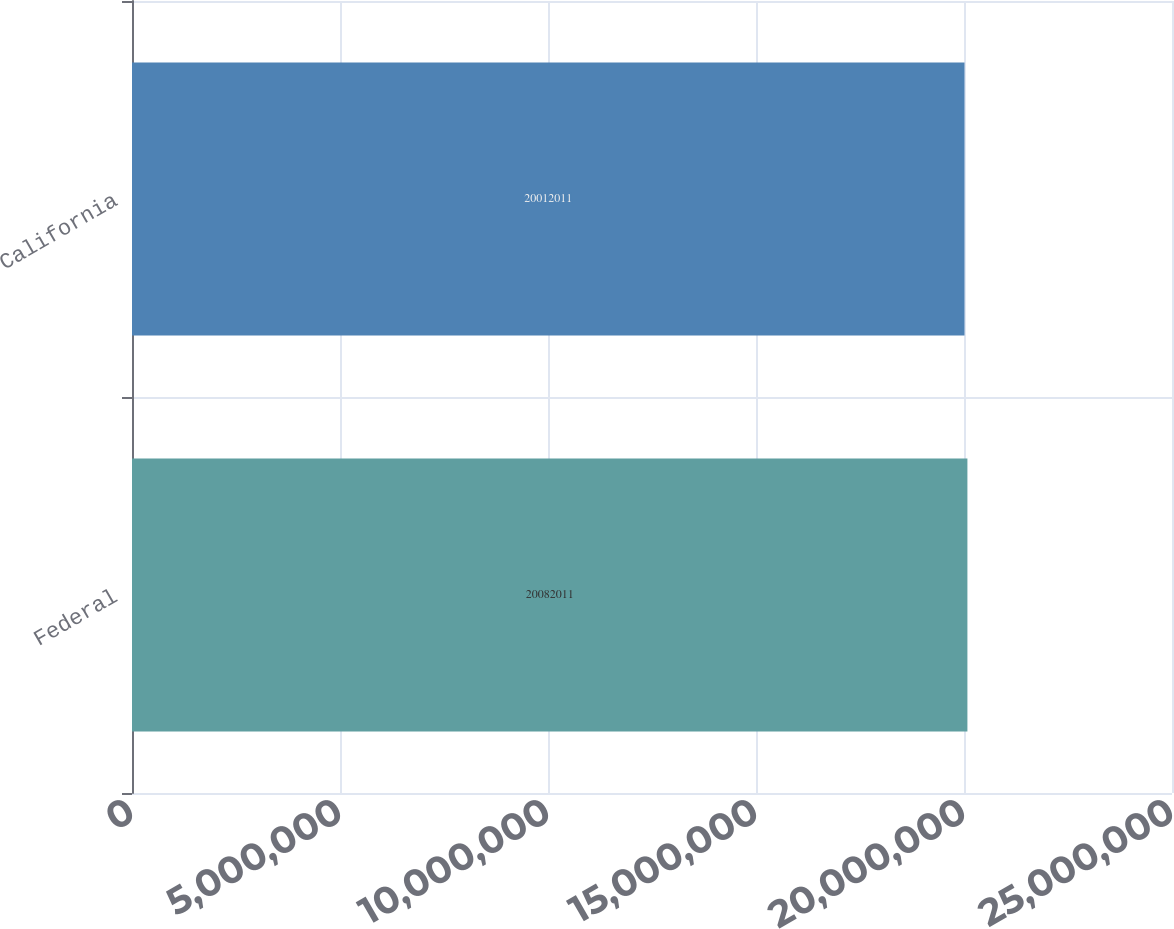Convert chart. <chart><loc_0><loc_0><loc_500><loc_500><bar_chart><fcel>Federal<fcel>California<nl><fcel>2.0082e+07<fcel>2.0012e+07<nl></chart> 